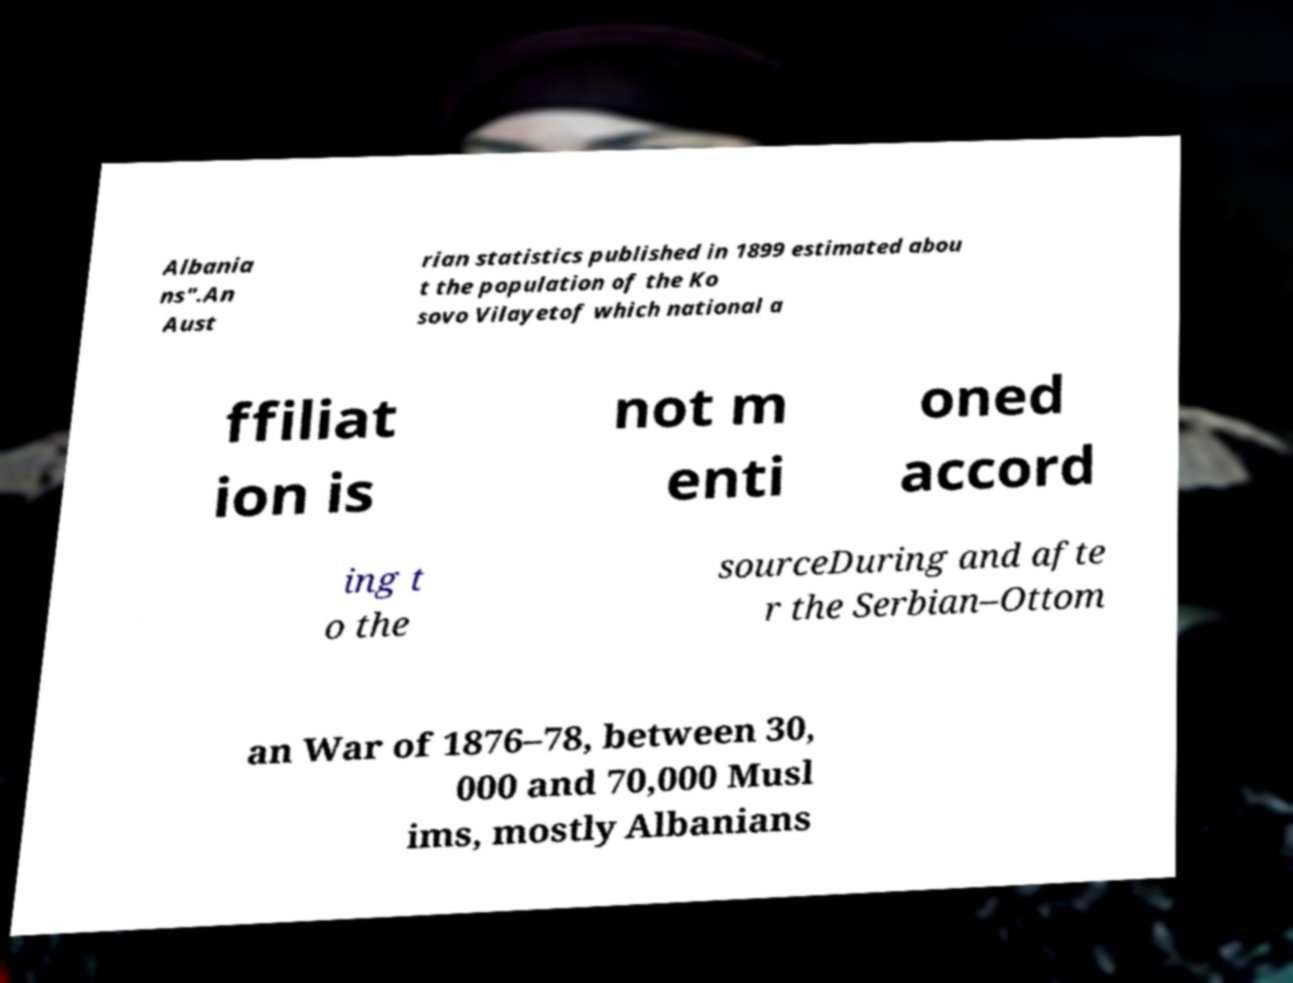Can you read and provide the text displayed in the image?This photo seems to have some interesting text. Can you extract and type it out for me? Albania ns".An Aust rian statistics published in 1899 estimated abou t the population of the Ko sovo Vilayetof which national a ffiliat ion is not m enti oned accord ing t o the sourceDuring and afte r the Serbian–Ottom an War of 1876–78, between 30, 000 and 70,000 Musl ims, mostly Albanians 